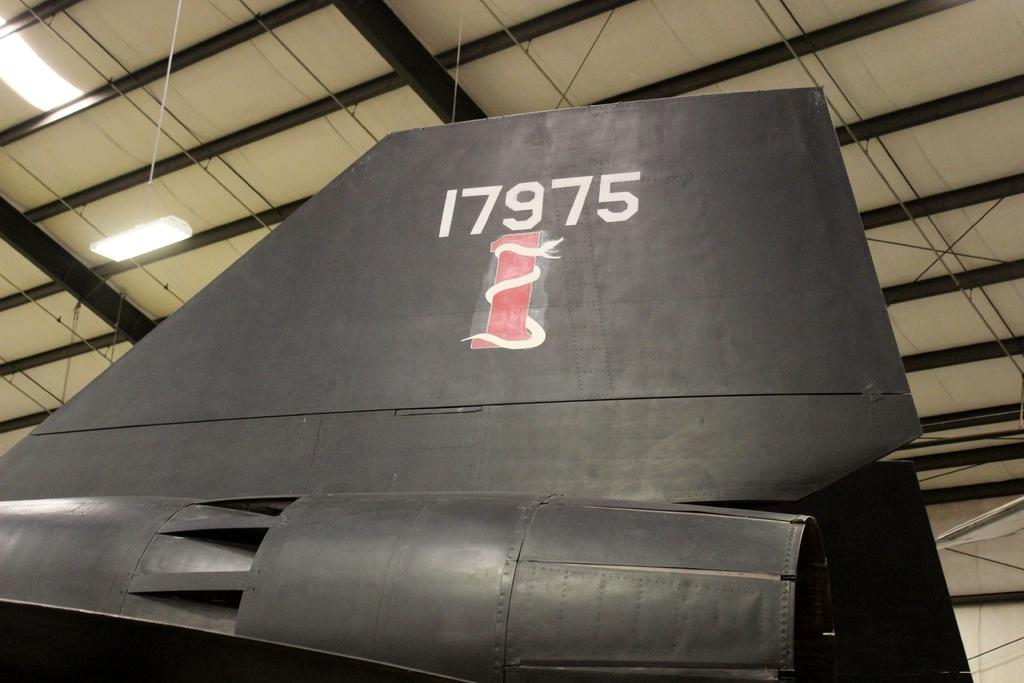<image>
Provide a brief description of the given image. Wing of a air craft with a snack around a red pole with the numbers 17975 